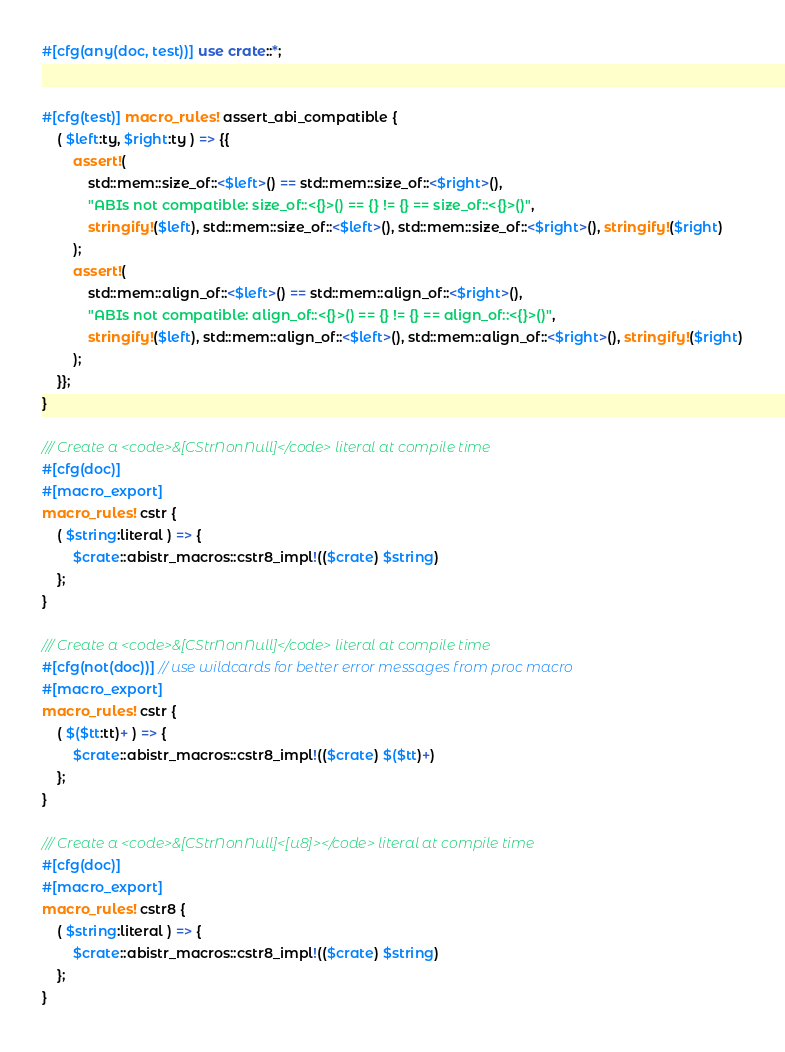Convert code to text. <code><loc_0><loc_0><loc_500><loc_500><_Rust_>#[cfg(any(doc, test))] use crate::*;


#[cfg(test)] macro_rules! assert_abi_compatible {
    ( $left:ty, $right:ty ) => {{
        assert!(
            std::mem::size_of::<$left>() == std::mem::size_of::<$right>(),
            "ABIs not compatible: size_of::<{}>() == {} != {} == size_of::<{}>()",
            stringify!($left), std::mem::size_of::<$left>(), std::mem::size_of::<$right>(), stringify!($right)
        );
        assert!(
            std::mem::align_of::<$left>() == std::mem::align_of::<$right>(),
            "ABIs not compatible: align_of::<{}>() == {} != {} == align_of::<{}>()",
            stringify!($left), std::mem::align_of::<$left>(), std::mem::align_of::<$right>(), stringify!($right)
        );
    }};
}

/// Create a <code>&[CStrNonNull]</code> literal at compile time
#[cfg(doc)]
#[macro_export]
macro_rules! cstr {
    ( $string:literal ) => {
        $crate::abistr_macros::cstr8_impl!(($crate) $string)
    };
}

/// Create a <code>&[CStrNonNull]</code> literal at compile time
#[cfg(not(doc))] // use wildcards for better error messages from proc macro
#[macro_export]
macro_rules! cstr {
    ( $($tt:tt)+ ) => {
        $crate::abistr_macros::cstr8_impl!(($crate) $($tt)+)
    };
}

/// Create a <code>&[CStrNonNull]<[u8]></code> literal at compile time
#[cfg(doc)]
#[macro_export]
macro_rules! cstr8 {
    ( $string:literal ) => {
        $crate::abistr_macros::cstr8_impl!(($crate) $string)
    };
}
</code> 